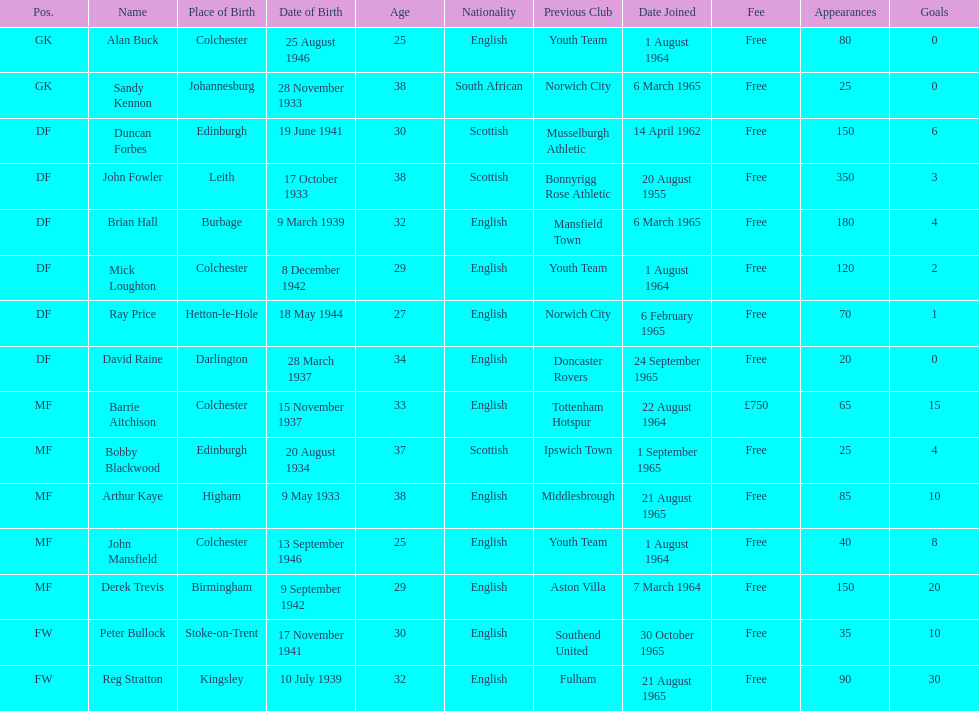Is arthur kaye older or younger than brian hill? Older. 